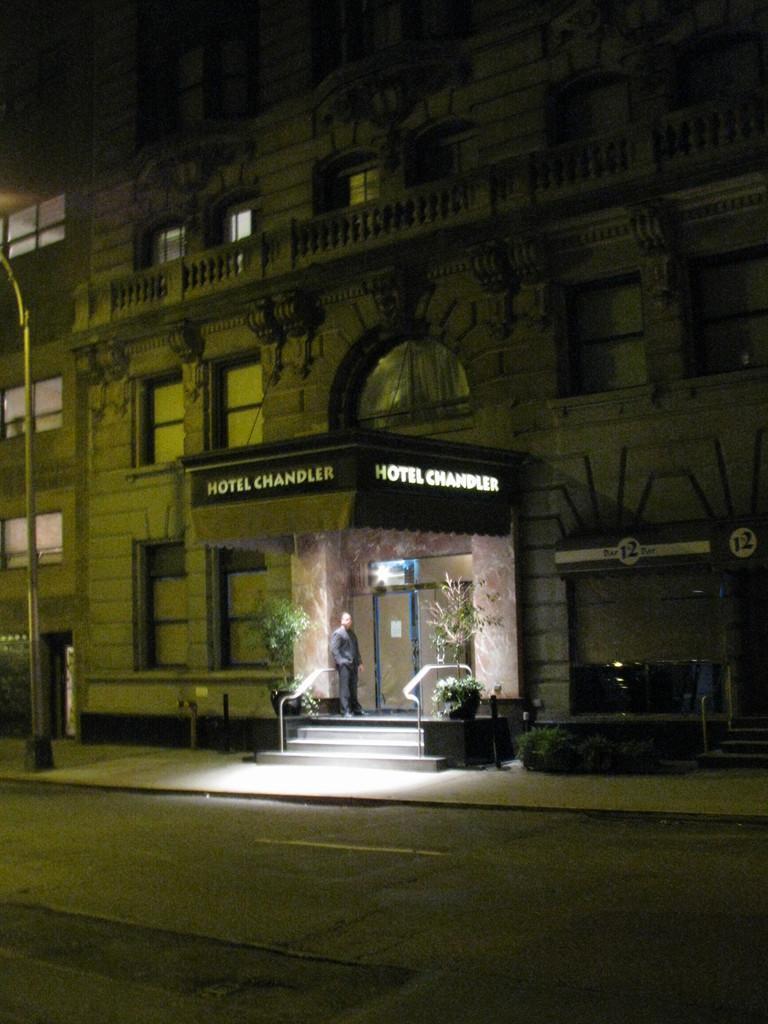Could you give a brief overview of what you see in this image? In this image, we can see a building and we can see the windows on the building, there is a person standing at the door, we can see the road. 